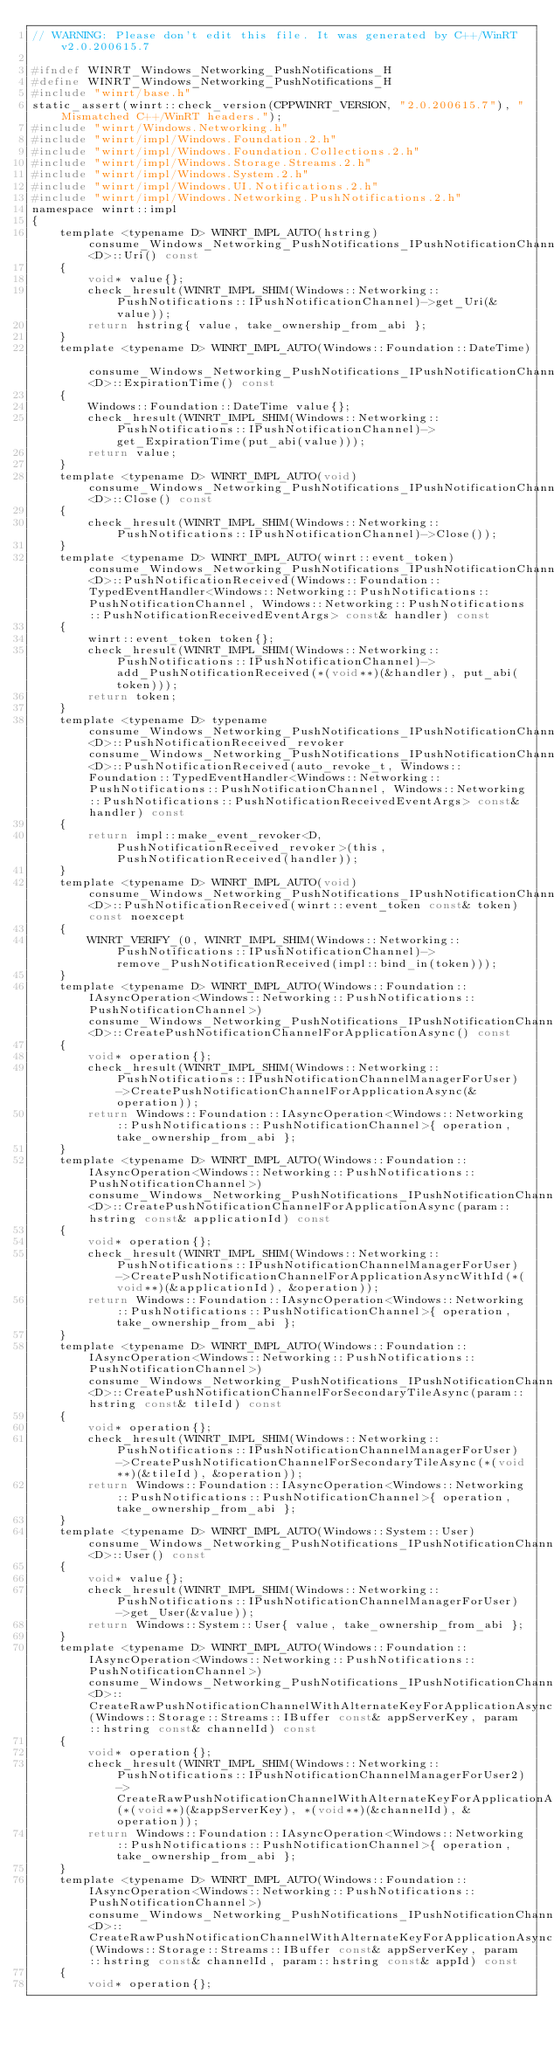<code> <loc_0><loc_0><loc_500><loc_500><_C_>// WARNING: Please don't edit this file. It was generated by C++/WinRT v2.0.200615.7

#ifndef WINRT_Windows_Networking_PushNotifications_H
#define WINRT_Windows_Networking_PushNotifications_H
#include "winrt/base.h"
static_assert(winrt::check_version(CPPWINRT_VERSION, "2.0.200615.7"), "Mismatched C++/WinRT headers.");
#include "winrt/Windows.Networking.h"
#include "winrt/impl/Windows.Foundation.2.h"
#include "winrt/impl/Windows.Foundation.Collections.2.h"
#include "winrt/impl/Windows.Storage.Streams.2.h"
#include "winrt/impl/Windows.System.2.h"
#include "winrt/impl/Windows.UI.Notifications.2.h"
#include "winrt/impl/Windows.Networking.PushNotifications.2.h"
namespace winrt::impl
{
    template <typename D> WINRT_IMPL_AUTO(hstring) consume_Windows_Networking_PushNotifications_IPushNotificationChannel<D>::Uri() const
    {
        void* value{};
        check_hresult(WINRT_IMPL_SHIM(Windows::Networking::PushNotifications::IPushNotificationChannel)->get_Uri(&value));
        return hstring{ value, take_ownership_from_abi };
    }
    template <typename D> WINRT_IMPL_AUTO(Windows::Foundation::DateTime) consume_Windows_Networking_PushNotifications_IPushNotificationChannel<D>::ExpirationTime() const
    {
        Windows::Foundation::DateTime value{};
        check_hresult(WINRT_IMPL_SHIM(Windows::Networking::PushNotifications::IPushNotificationChannel)->get_ExpirationTime(put_abi(value)));
        return value;
    }
    template <typename D> WINRT_IMPL_AUTO(void) consume_Windows_Networking_PushNotifications_IPushNotificationChannel<D>::Close() const
    {
        check_hresult(WINRT_IMPL_SHIM(Windows::Networking::PushNotifications::IPushNotificationChannel)->Close());
    }
    template <typename D> WINRT_IMPL_AUTO(winrt::event_token) consume_Windows_Networking_PushNotifications_IPushNotificationChannel<D>::PushNotificationReceived(Windows::Foundation::TypedEventHandler<Windows::Networking::PushNotifications::PushNotificationChannel, Windows::Networking::PushNotifications::PushNotificationReceivedEventArgs> const& handler) const
    {
        winrt::event_token token{};
        check_hresult(WINRT_IMPL_SHIM(Windows::Networking::PushNotifications::IPushNotificationChannel)->add_PushNotificationReceived(*(void**)(&handler), put_abi(token)));
        return token;
    }
    template <typename D> typename consume_Windows_Networking_PushNotifications_IPushNotificationChannel<D>::PushNotificationReceived_revoker consume_Windows_Networking_PushNotifications_IPushNotificationChannel<D>::PushNotificationReceived(auto_revoke_t, Windows::Foundation::TypedEventHandler<Windows::Networking::PushNotifications::PushNotificationChannel, Windows::Networking::PushNotifications::PushNotificationReceivedEventArgs> const& handler) const
    {
        return impl::make_event_revoker<D, PushNotificationReceived_revoker>(this, PushNotificationReceived(handler));
    }
    template <typename D> WINRT_IMPL_AUTO(void) consume_Windows_Networking_PushNotifications_IPushNotificationChannel<D>::PushNotificationReceived(winrt::event_token const& token) const noexcept
    {
        WINRT_VERIFY_(0, WINRT_IMPL_SHIM(Windows::Networking::PushNotifications::IPushNotificationChannel)->remove_PushNotificationReceived(impl::bind_in(token)));
    }
    template <typename D> WINRT_IMPL_AUTO(Windows::Foundation::IAsyncOperation<Windows::Networking::PushNotifications::PushNotificationChannel>) consume_Windows_Networking_PushNotifications_IPushNotificationChannelManagerForUser<D>::CreatePushNotificationChannelForApplicationAsync() const
    {
        void* operation{};
        check_hresult(WINRT_IMPL_SHIM(Windows::Networking::PushNotifications::IPushNotificationChannelManagerForUser)->CreatePushNotificationChannelForApplicationAsync(&operation));
        return Windows::Foundation::IAsyncOperation<Windows::Networking::PushNotifications::PushNotificationChannel>{ operation, take_ownership_from_abi };
    }
    template <typename D> WINRT_IMPL_AUTO(Windows::Foundation::IAsyncOperation<Windows::Networking::PushNotifications::PushNotificationChannel>) consume_Windows_Networking_PushNotifications_IPushNotificationChannelManagerForUser<D>::CreatePushNotificationChannelForApplicationAsync(param::hstring const& applicationId) const
    {
        void* operation{};
        check_hresult(WINRT_IMPL_SHIM(Windows::Networking::PushNotifications::IPushNotificationChannelManagerForUser)->CreatePushNotificationChannelForApplicationAsyncWithId(*(void**)(&applicationId), &operation));
        return Windows::Foundation::IAsyncOperation<Windows::Networking::PushNotifications::PushNotificationChannel>{ operation, take_ownership_from_abi };
    }
    template <typename D> WINRT_IMPL_AUTO(Windows::Foundation::IAsyncOperation<Windows::Networking::PushNotifications::PushNotificationChannel>) consume_Windows_Networking_PushNotifications_IPushNotificationChannelManagerForUser<D>::CreatePushNotificationChannelForSecondaryTileAsync(param::hstring const& tileId) const
    {
        void* operation{};
        check_hresult(WINRT_IMPL_SHIM(Windows::Networking::PushNotifications::IPushNotificationChannelManagerForUser)->CreatePushNotificationChannelForSecondaryTileAsync(*(void**)(&tileId), &operation));
        return Windows::Foundation::IAsyncOperation<Windows::Networking::PushNotifications::PushNotificationChannel>{ operation, take_ownership_from_abi };
    }
    template <typename D> WINRT_IMPL_AUTO(Windows::System::User) consume_Windows_Networking_PushNotifications_IPushNotificationChannelManagerForUser<D>::User() const
    {
        void* value{};
        check_hresult(WINRT_IMPL_SHIM(Windows::Networking::PushNotifications::IPushNotificationChannelManagerForUser)->get_User(&value));
        return Windows::System::User{ value, take_ownership_from_abi };
    }
    template <typename D> WINRT_IMPL_AUTO(Windows::Foundation::IAsyncOperation<Windows::Networking::PushNotifications::PushNotificationChannel>) consume_Windows_Networking_PushNotifications_IPushNotificationChannelManagerForUser2<D>::CreateRawPushNotificationChannelWithAlternateKeyForApplicationAsync(Windows::Storage::Streams::IBuffer const& appServerKey, param::hstring const& channelId) const
    {
        void* operation{};
        check_hresult(WINRT_IMPL_SHIM(Windows::Networking::PushNotifications::IPushNotificationChannelManagerForUser2)->CreateRawPushNotificationChannelWithAlternateKeyForApplicationAsync(*(void**)(&appServerKey), *(void**)(&channelId), &operation));
        return Windows::Foundation::IAsyncOperation<Windows::Networking::PushNotifications::PushNotificationChannel>{ operation, take_ownership_from_abi };
    }
    template <typename D> WINRT_IMPL_AUTO(Windows::Foundation::IAsyncOperation<Windows::Networking::PushNotifications::PushNotificationChannel>) consume_Windows_Networking_PushNotifications_IPushNotificationChannelManagerForUser2<D>::CreateRawPushNotificationChannelWithAlternateKeyForApplicationAsync(Windows::Storage::Streams::IBuffer const& appServerKey, param::hstring const& channelId, param::hstring const& appId) const
    {
        void* operation{};</code> 